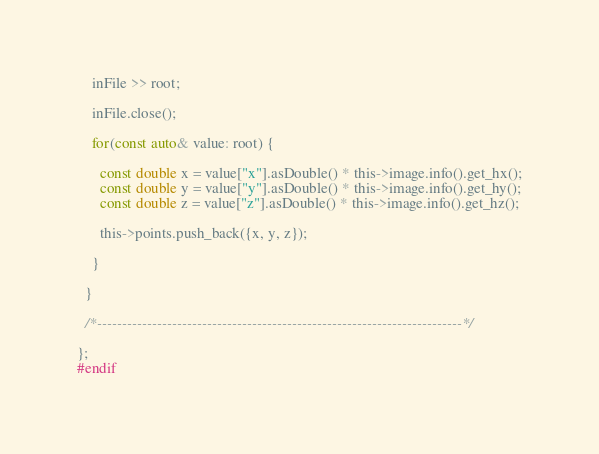<code> <loc_0><loc_0><loc_500><loc_500><_C_>    inFile >> root;

    inFile.close();

    for(const auto& value: root) {

      const double x = value["x"].asDouble() * this->image.info().get_hx();
      const double y = value["y"].asDouble() * this->image.info().get_hy();
      const double z = value["z"].asDouble() * this->image.info().get_hz();

      this->points.push_back({x, y, z});

    }

  }

  /*-------------------------------------------------------------------------*/

};
#endif
</code> 